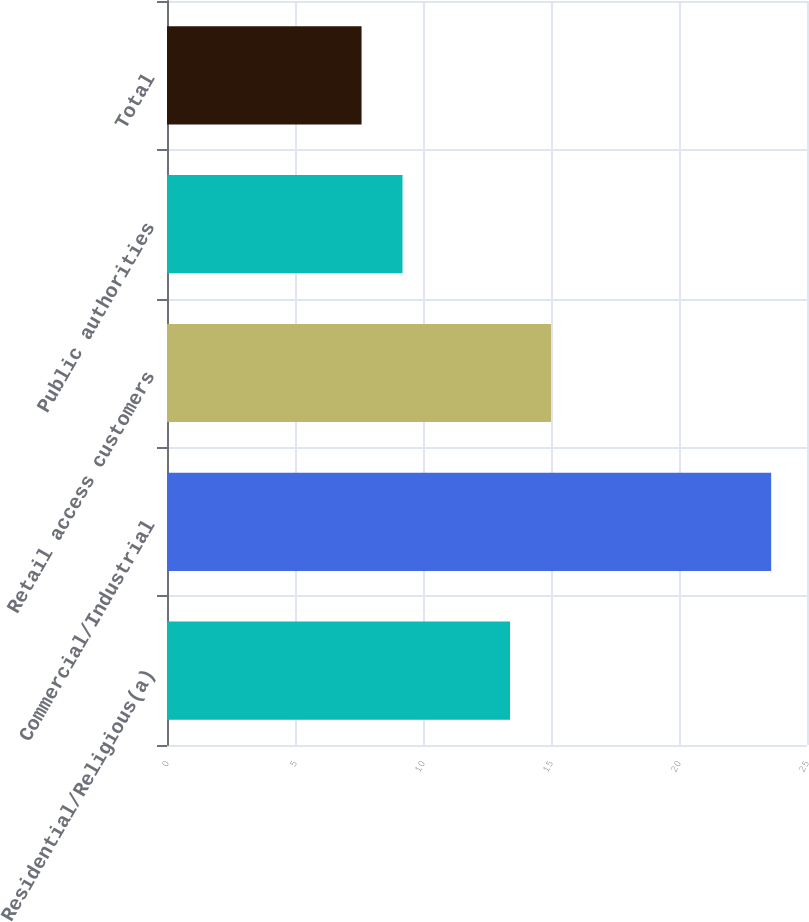<chart> <loc_0><loc_0><loc_500><loc_500><bar_chart><fcel>Residential/Religious(a)<fcel>Commercial/Industrial<fcel>Retail access customers<fcel>Public authorities<fcel>Total<nl><fcel>13.4<fcel>23.6<fcel>15<fcel>9.2<fcel>7.6<nl></chart> 